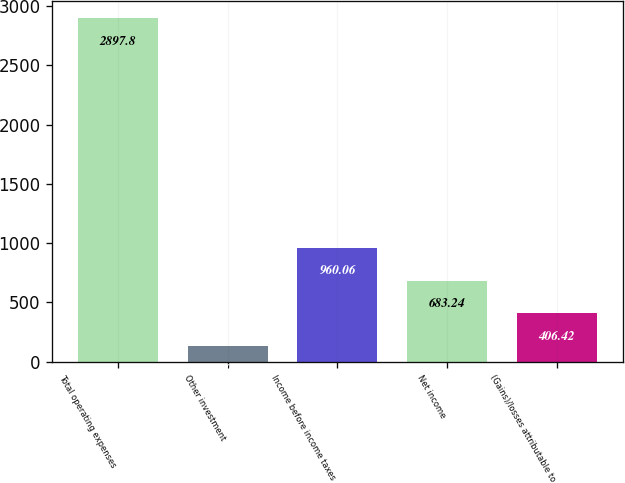<chart> <loc_0><loc_0><loc_500><loc_500><bar_chart><fcel>Total operating expenses<fcel>Other investment<fcel>Income before income taxes<fcel>Net income<fcel>(Gains)/losses attributable to<nl><fcel>2897.8<fcel>129.6<fcel>960.06<fcel>683.24<fcel>406.42<nl></chart> 